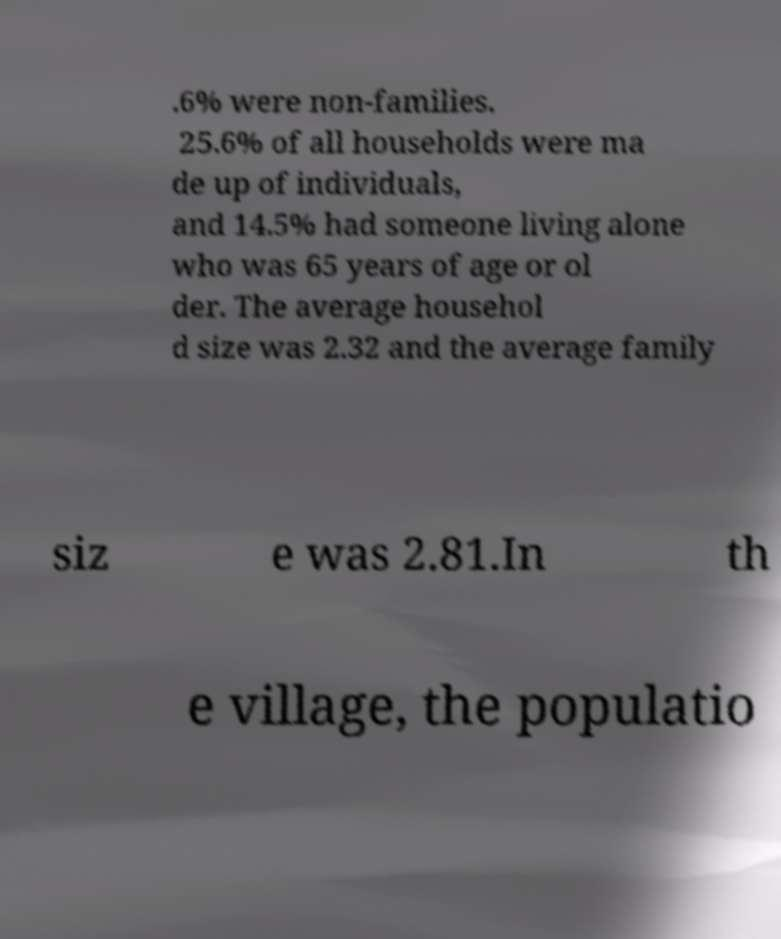There's text embedded in this image that I need extracted. Can you transcribe it verbatim? .6% were non-families. 25.6% of all households were ma de up of individuals, and 14.5% had someone living alone who was 65 years of age or ol der. The average househol d size was 2.32 and the average family siz e was 2.81.In th e village, the populatio 